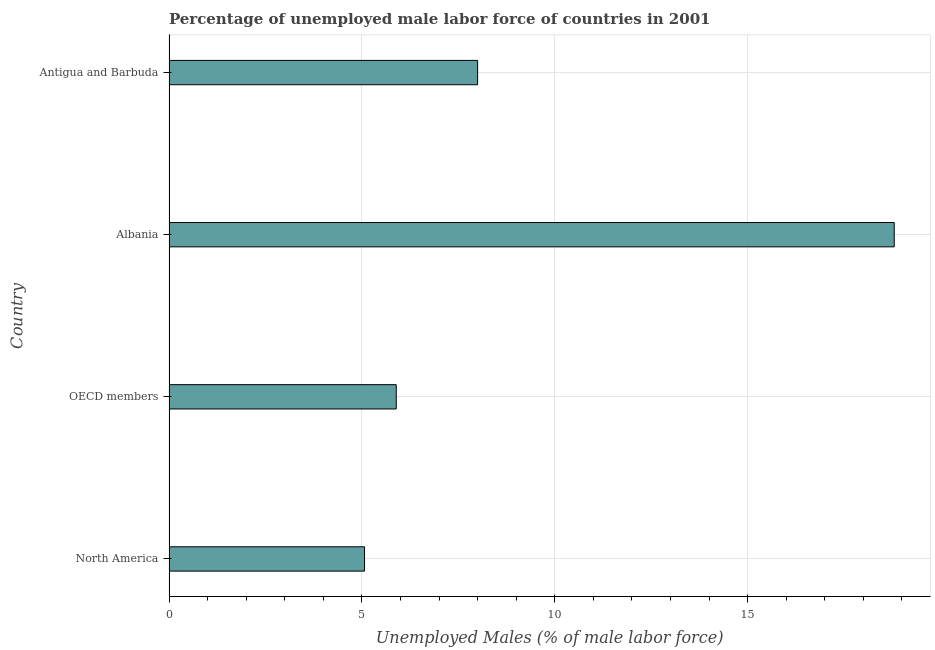Does the graph contain any zero values?
Offer a terse response. No. What is the title of the graph?
Give a very brief answer. Percentage of unemployed male labor force of countries in 2001. What is the label or title of the X-axis?
Your answer should be compact. Unemployed Males (% of male labor force). What is the total unemployed male labour force in Albania?
Ensure brevity in your answer.  18.8. Across all countries, what is the maximum total unemployed male labour force?
Your response must be concise. 18.8. Across all countries, what is the minimum total unemployed male labour force?
Keep it short and to the point. 5.07. In which country was the total unemployed male labour force maximum?
Provide a short and direct response. Albania. What is the sum of the total unemployed male labour force?
Ensure brevity in your answer.  37.76. What is the difference between the total unemployed male labour force in North America and OECD members?
Provide a succinct answer. -0.82. What is the average total unemployed male labour force per country?
Your response must be concise. 9.44. What is the median total unemployed male labour force?
Offer a terse response. 6.95. What is the ratio of the total unemployed male labour force in Albania to that in OECD members?
Your response must be concise. 3.19. Is the total unemployed male labour force in Antigua and Barbuda less than that in OECD members?
Your answer should be compact. No. What is the difference between the highest and the second highest total unemployed male labour force?
Your answer should be very brief. 10.8. Is the sum of the total unemployed male labour force in Albania and OECD members greater than the maximum total unemployed male labour force across all countries?
Your answer should be compact. Yes. What is the difference between the highest and the lowest total unemployed male labour force?
Your response must be concise. 13.73. In how many countries, is the total unemployed male labour force greater than the average total unemployed male labour force taken over all countries?
Provide a short and direct response. 1. Are all the bars in the graph horizontal?
Give a very brief answer. Yes. How many countries are there in the graph?
Ensure brevity in your answer.  4. Are the values on the major ticks of X-axis written in scientific E-notation?
Your response must be concise. No. What is the Unemployed Males (% of male labor force) in North America?
Your response must be concise. 5.07. What is the Unemployed Males (% of male labor force) in OECD members?
Offer a very short reply. 5.89. What is the Unemployed Males (% of male labor force) in Albania?
Your answer should be very brief. 18.8. What is the difference between the Unemployed Males (% of male labor force) in North America and OECD members?
Offer a very short reply. -0.82. What is the difference between the Unemployed Males (% of male labor force) in North America and Albania?
Your response must be concise. -13.73. What is the difference between the Unemployed Males (% of male labor force) in North America and Antigua and Barbuda?
Give a very brief answer. -2.93. What is the difference between the Unemployed Males (% of male labor force) in OECD members and Albania?
Your response must be concise. -12.91. What is the difference between the Unemployed Males (% of male labor force) in OECD members and Antigua and Barbuda?
Provide a short and direct response. -2.11. What is the ratio of the Unemployed Males (% of male labor force) in North America to that in OECD members?
Keep it short and to the point. 0.86. What is the ratio of the Unemployed Males (% of male labor force) in North America to that in Albania?
Your answer should be compact. 0.27. What is the ratio of the Unemployed Males (% of male labor force) in North America to that in Antigua and Barbuda?
Provide a short and direct response. 0.63. What is the ratio of the Unemployed Males (% of male labor force) in OECD members to that in Albania?
Make the answer very short. 0.31. What is the ratio of the Unemployed Males (% of male labor force) in OECD members to that in Antigua and Barbuda?
Your response must be concise. 0.74. What is the ratio of the Unemployed Males (% of male labor force) in Albania to that in Antigua and Barbuda?
Ensure brevity in your answer.  2.35. 